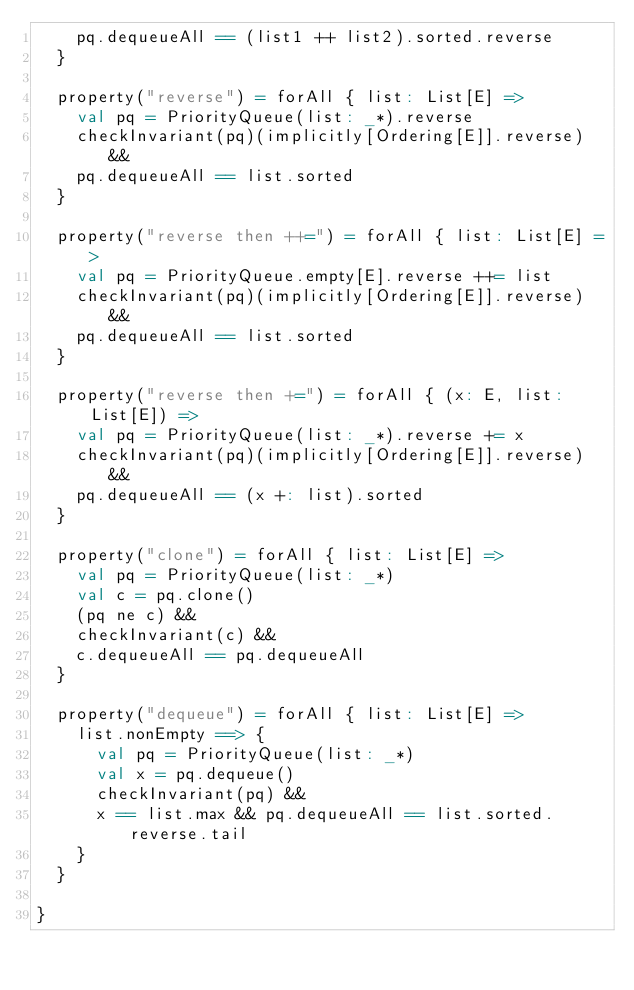<code> <loc_0><loc_0><loc_500><loc_500><_Scala_>    pq.dequeueAll == (list1 ++ list2).sorted.reverse
  }

  property("reverse") = forAll { list: List[E] =>
    val pq = PriorityQueue(list: _*).reverse
    checkInvariant(pq)(implicitly[Ordering[E]].reverse) &&
    pq.dequeueAll == list.sorted
  }

  property("reverse then ++=") = forAll { list: List[E] =>
    val pq = PriorityQueue.empty[E].reverse ++= list
    checkInvariant(pq)(implicitly[Ordering[E]].reverse) &&
    pq.dequeueAll == list.sorted
  }

  property("reverse then +=") = forAll { (x: E, list: List[E]) =>
    val pq = PriorityQueue(list: _*).reverse += x
    checkInvariant(pq)(implicitly[Ordering[E]].reverse) &&
    pq.dequeueAll == (x +: list).sorted
  }

  property("clone") = forAll { list: List[E] =>
    val pq = PriorityQueue(list: _*)
    val c = pq.clone()
    (pq ne c) &&
    checkInvariant(c) &&
    c.dequeueAll == pq.dequeueAll
  }

  property("dequeue") = forAll { list: List[E] =>
    list.nonEmpty ==> {
      val pq = PriorityQueue(list: _*)
      val x = pq.dequeue()
      checkInvariant(pq) &&
      x == list.max && pq.dequeueAll == list.sorted.reverse.tail
    }
  }

}
</code> 